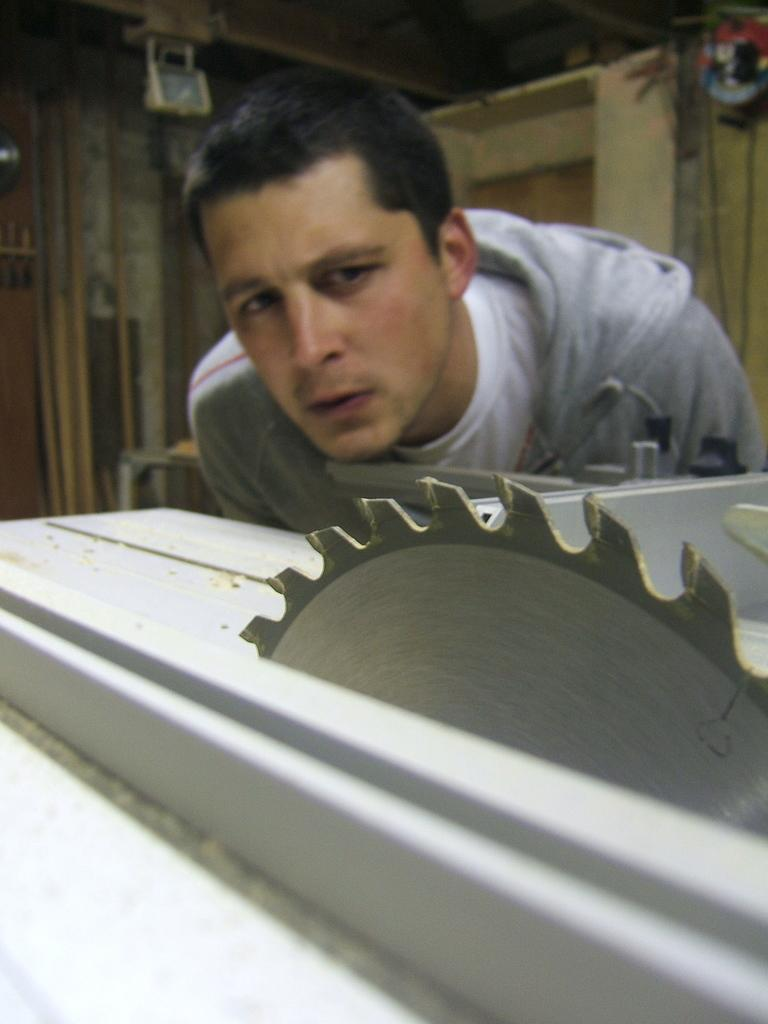Who or what is the main subject in the center of the image? There is a person in the center of the image. What is the person wearing? The person is wearing a jacket. What can be seen at the bottom of the image? There are blades visible at the bottom of the image. What is the person's hourly income in the image? There is no information about the person's income in the image. Is there a lamp present in the image? There is no lamp visible in the image. 